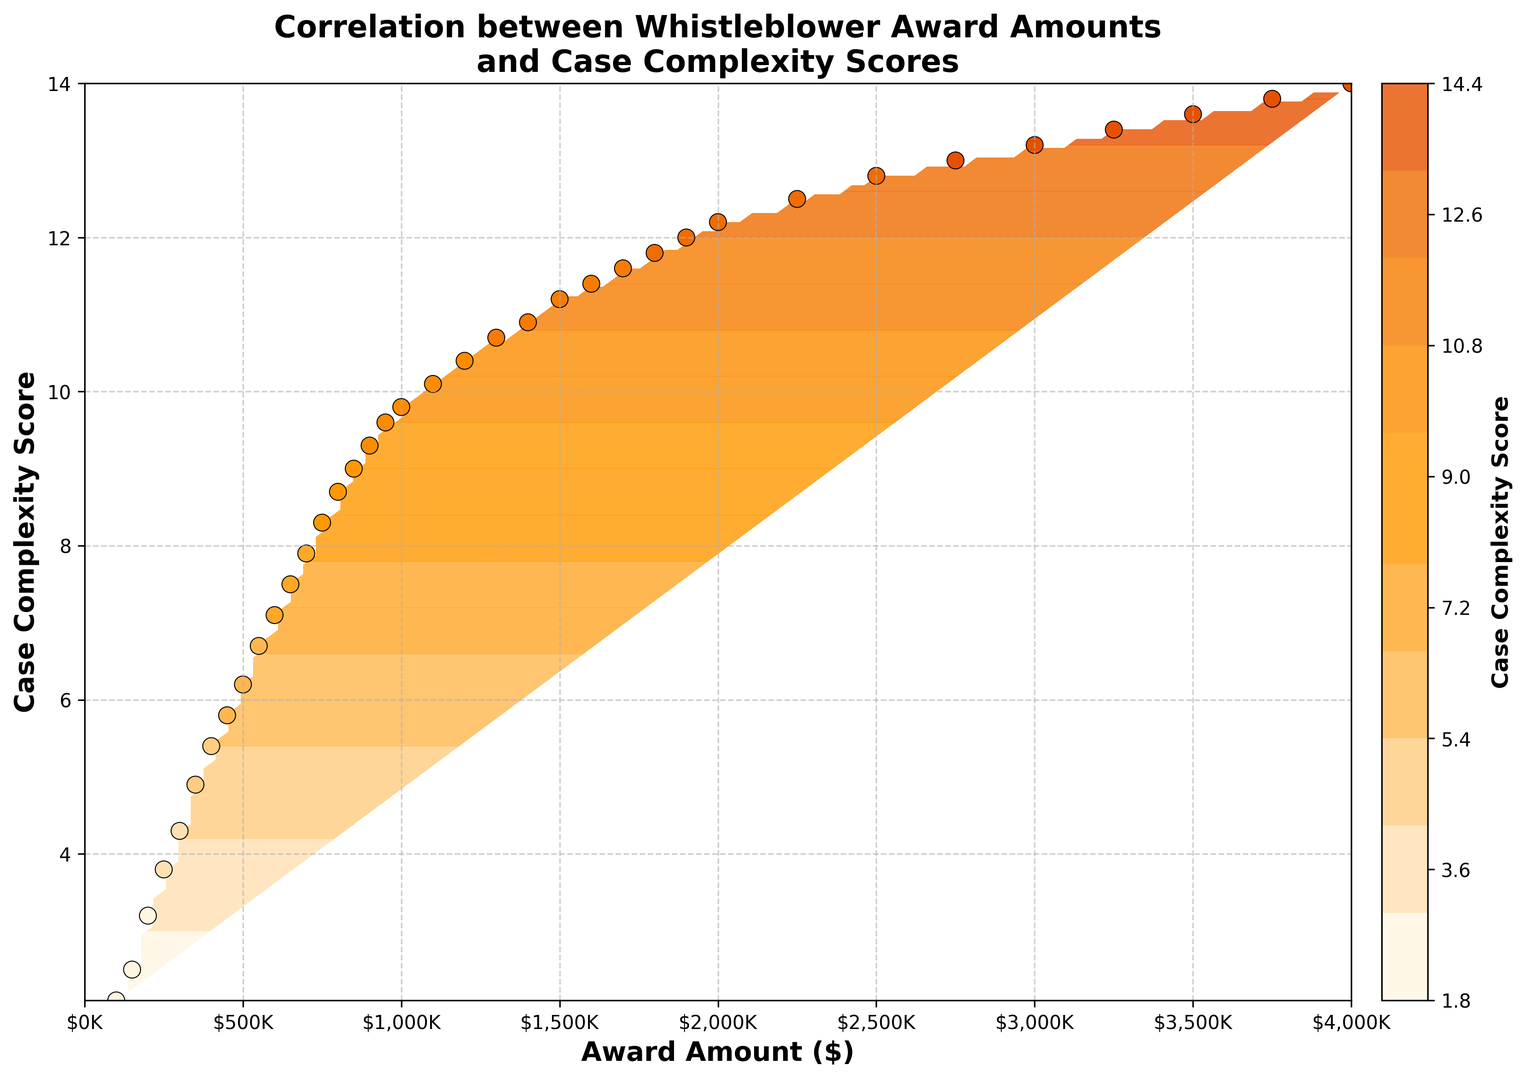What does a high concentration of colored lines in the figure indicate? A high concentration of contour lines indicates areas where the case complexity score changes rapidly in comparison to award amounts. These regions suggest strong correlations.
Answer: Areas of rapid change Is there a noticeable trend between whistleblower award amounts and case complexity scores? The contour plot shows a clear upward trend, indicating that as whistleblower award amounts increase, the case complexity scores also tend to increase.
Answer: Positive correlation What is the award amount range corresponding to the highest case complexity scores? The highest case complexity scores are found in regions where whistleblower award amounts range from approximately $1,800,000 to $4,000,000. This can be derived by observing the top right region of the contour plot.
Answer: $1,800,000 to $4,000,000 Are there any specific regions where the case complexity score remains constant despite changes in award amounts? There are few such regions, but one noticeable area is where the award amount is between $1,000,000 and $2,000,000, and the complexity score stabilizes around 9 to 10. Contour lines in these regions are relatively sparse.
Answer: Around $1,000,000 to $2,000,000 How does the color of the highest data points on the plot compare to the rest? The highest data points on the plot, which correspond to the complex cases, tend to utilize darker shades of orange to brown. These are at the higher end of the colormap gradient.
Answer: Dark orange to brown What is the effect on case complexity score with an increase from $100,000 to $1,000,000 in award amount? Observing the contour plot, an increase from $100,000 to $1,000,000 in award amount results in an approximately linear increase in case complexity score from 2.1 to around 9.5.
Answer: Increase from 2.1 to around 9.5 Which range of award amounts has the most variation in case complexity scores? The range between $500,000 and $1,000,000 exhibits significant variation in case complexity scores, spanning from approximately 6.2 to 9.5. The concentration of contour lines is dense in this region, indicating high variability.
Answer: $500,000 to $1,000,000 What is the case complexity score when the award amount is $2,500,000? Looking at the contour lines and the scatter points, the case complexity score at an award amount of $2,500,000 appears to be approximately 12.8.
Answer: Approximately 12.8 